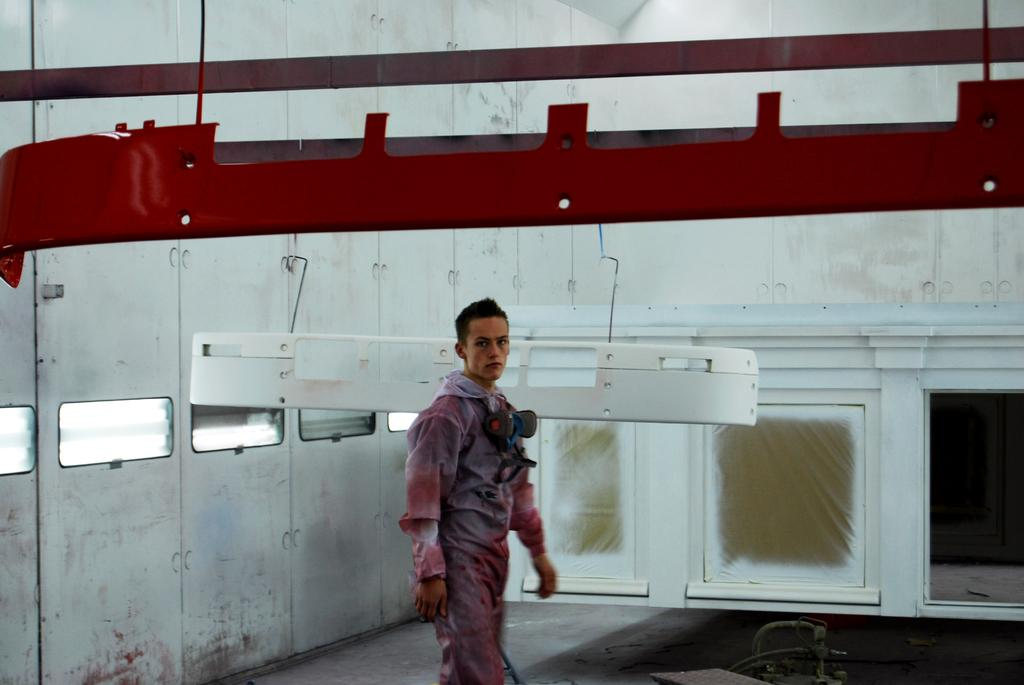What is the man in the image doing? The man is walking in the image. On what surface is the man walking? The man is walking on the floor. What can be seen on the wall in the image? There are windows on the wall. What is hanging from the ceiling in the image? Metal rods are hanging from the ceiling. Can you see a sea in the image? No, there is no sea present in the image. What type of branch is the man holding in the image? There is no branch present in the image; the man is simply walking. 